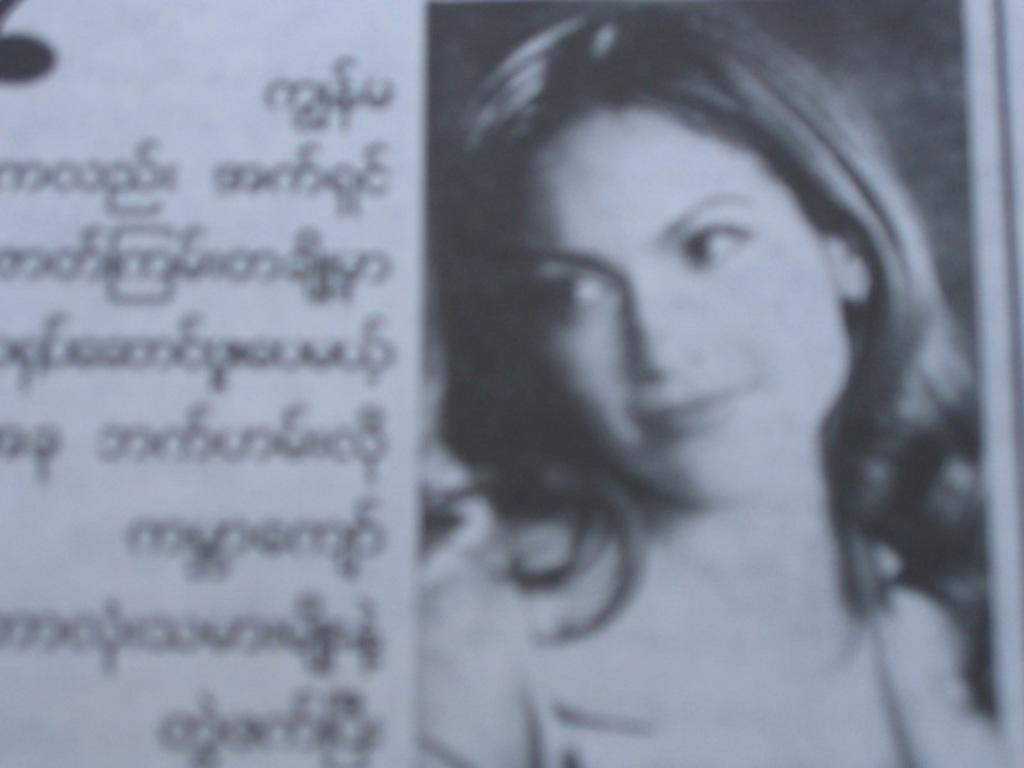What type of image is depicted in the photograph? There is a news photograph in the image. Who is present in the news photograph? There is a girl in the image. What is the girl's expression in the photograph? The girl is smiling in the photograph. In which direction is the girl looking? The girl is looking to the left side in the photograph. What can be seen on the paper in the image? There is some matter (text or content) on the paper. What type of car is the girl driving in the image? There is no car present in the image; it is a news photograph featuring a girl. How much debt does the girl have in the image? There is no mention of debt in the image; it is a news photograph featuring a girl. 